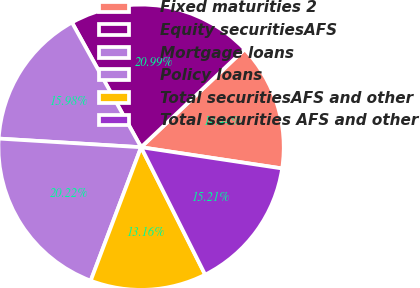<chart> <loc_0><loc_0><loc_500><loc_500><pie_chart><fcel>Fixed maturities 2<fcel>Equity securitiesAFS<fcel>Mortgage loans<fcel>Policy loans<fcel>Total securitiesAFS and other<fcel>Total securities AFS and other<nl><fcel>14.44%<fcel>20.99%<fcel>15.98%<fcel>20.22%<fcel>13.16%<fcel>15.21%<nl></chart> 